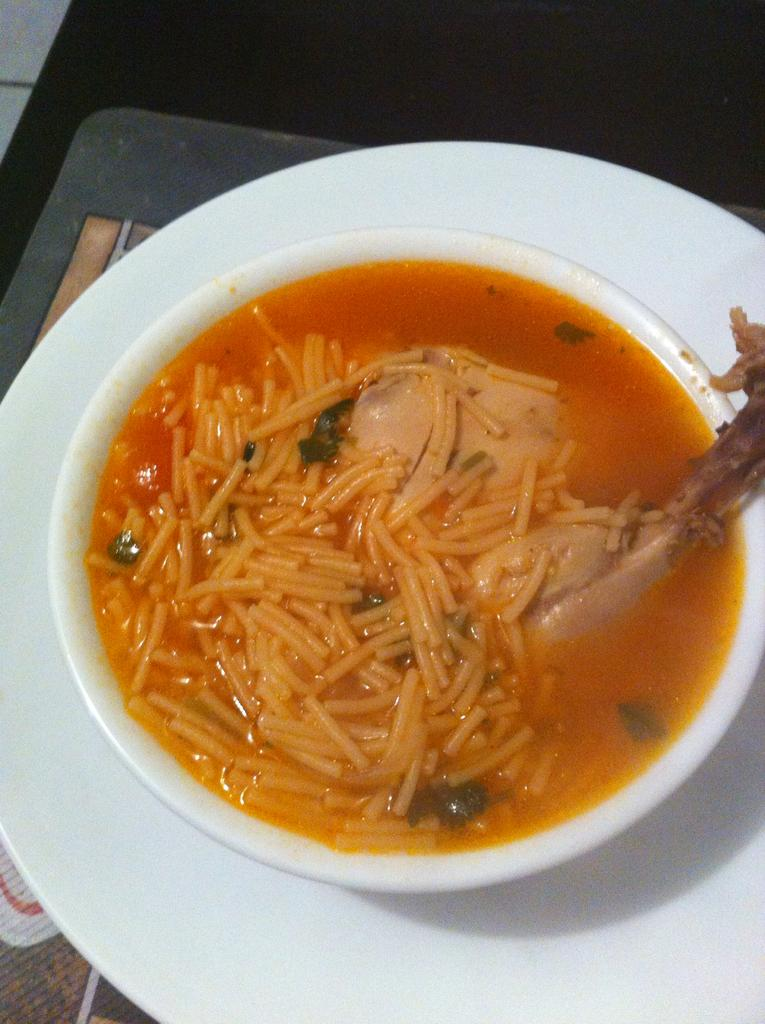What is in the bowl that is visible in the image? There is a bowl with noodles in it. What is the bowl placed on? The bowl is placed on a plate. What type of screw can be seen holding the stage together in the image? There is no stage or screw present in the image; it features a bowl of noodles placed on a plate. Who is the creator of the noodles in the image? The image does not provide information about the creator of the noodles. 